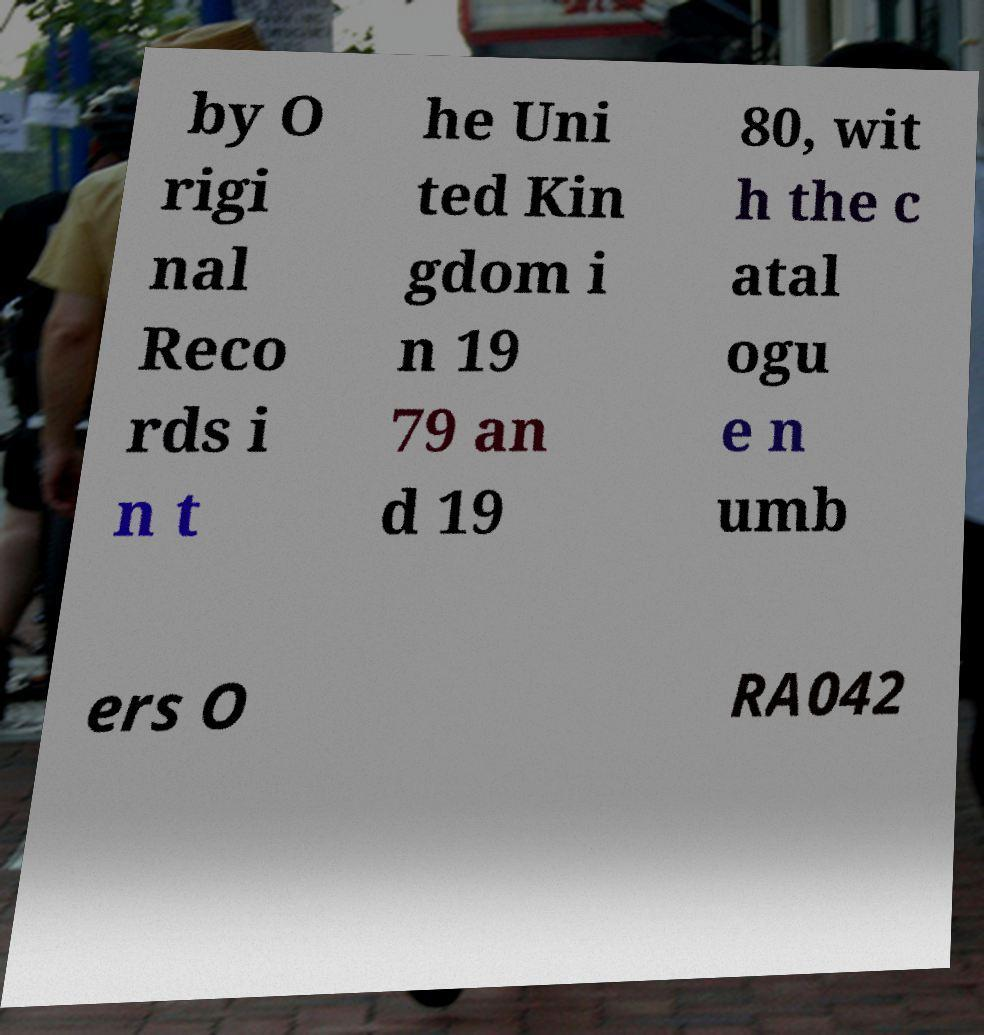Could you extract and type out the text from this image? by O rigi nal Reco rds i n t he Uni ted Kin gdom i n 19 79 an d 19 80, wit h the c atal ogu e n umb ers O RA042 